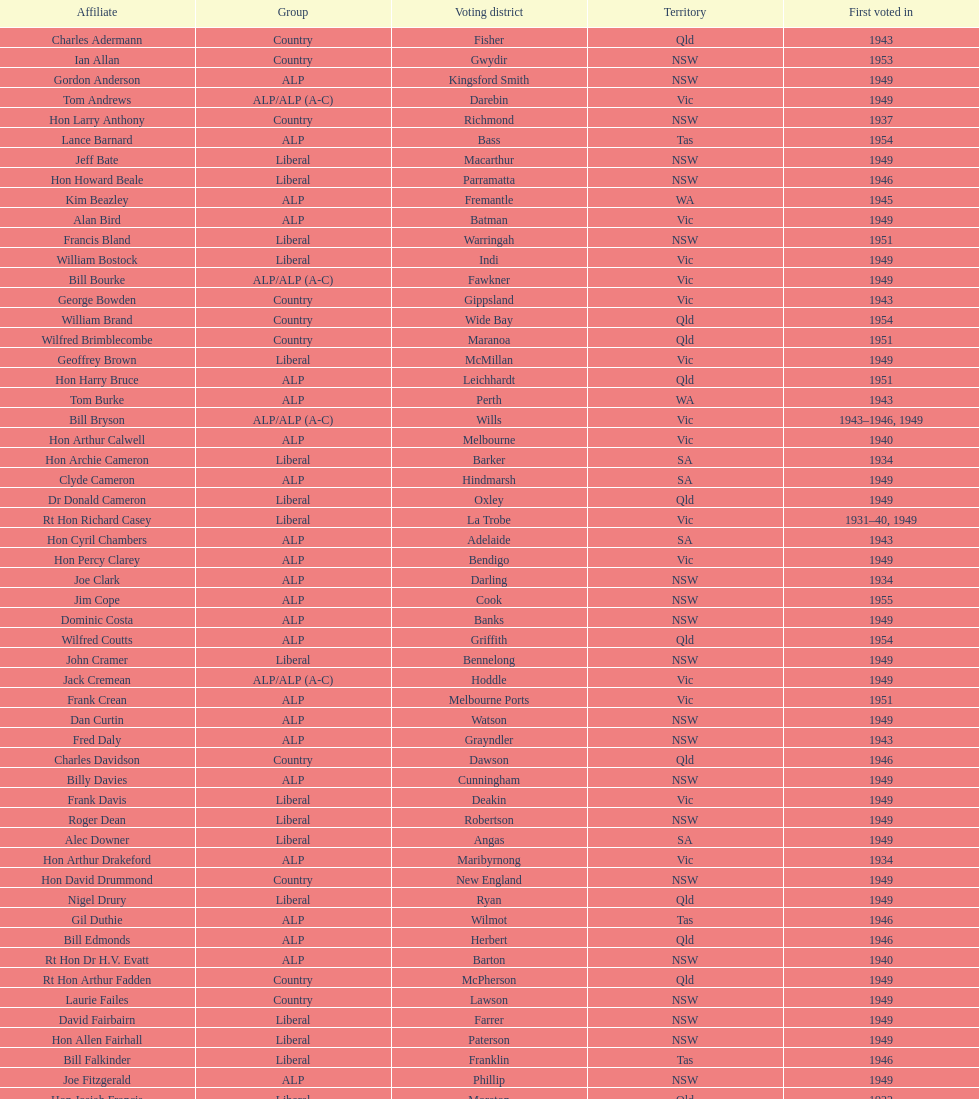What is the number of alp party members elected? 57. 